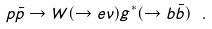Convert formula to latex. <formula><loc_0><loc_0><loc_500><loc_500>p \bar { p } \rightarrow W ( \rightarrow e \nu ) g ^ { * } ( \rightarrow b \bar { b } ) \ .</formula> 